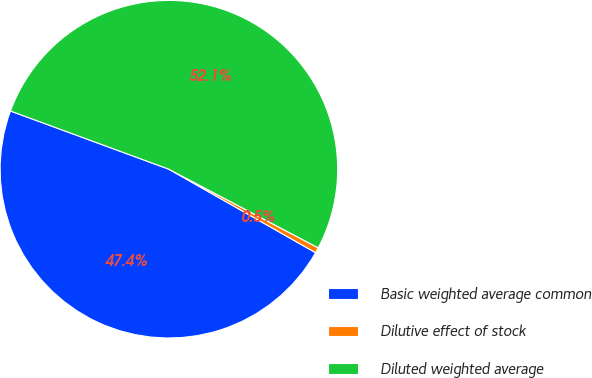<chart> <loc_0><loc_0><loc_500><loc_500><pie_chart><fcel>Basic weighted average common<fcel>Dilutive effect of stock<fcel>Diluted weighted average<nl><fcel>47.37%<fcel>0.52%<fcel>52.11%<nl></chart> 